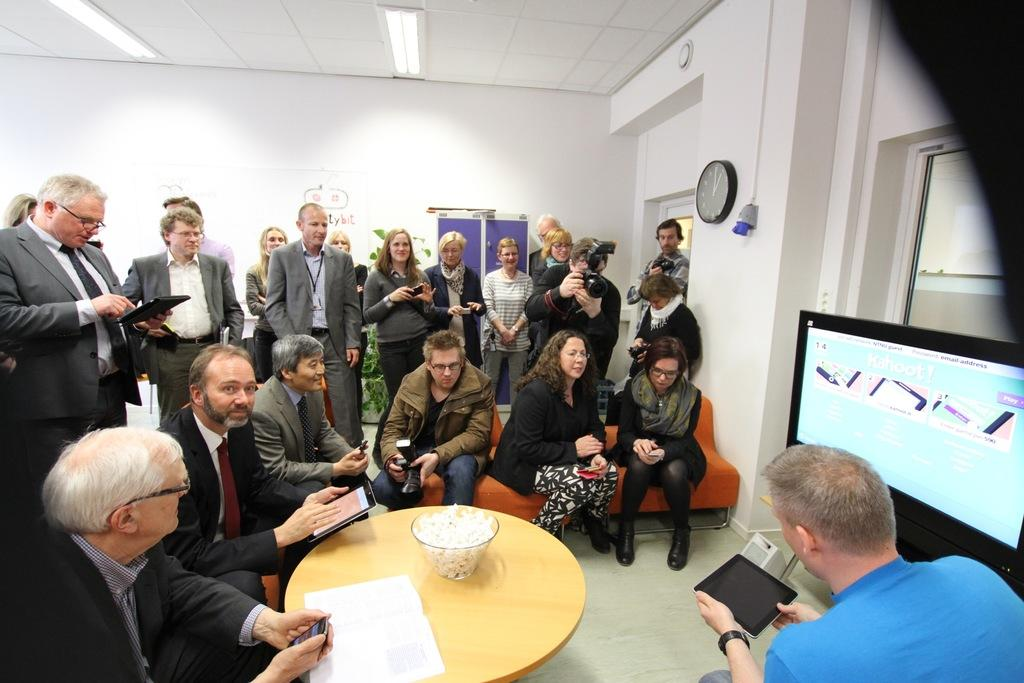What is the main subject of the image? The main subject of the image is a group of people. What are the people in the image doing? The group of people are watching a screen. Can you describe the man's position in the image? There is a man beside the screen. What type of insect can be seen crawling on the screen in the image? There is no insect present on the screen in the image. 